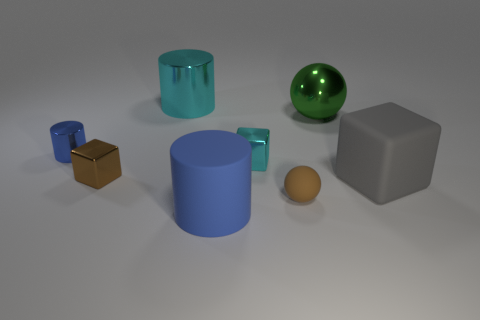Add 2 large blue shiny cubes. How many objects exist? 10 Subtract all blocks. How many objects are left? 5 Subtract all tiny red metal objects. Subtract all gray matte blocks. How many objects are left? 7 Add 8 small matte balls. How many small matte balls are left? 9 Add 2 big cyan cylinders. How many big cyan cylinders exist? 3 Subtract 0 green cylinders. How many objects are left? 8 